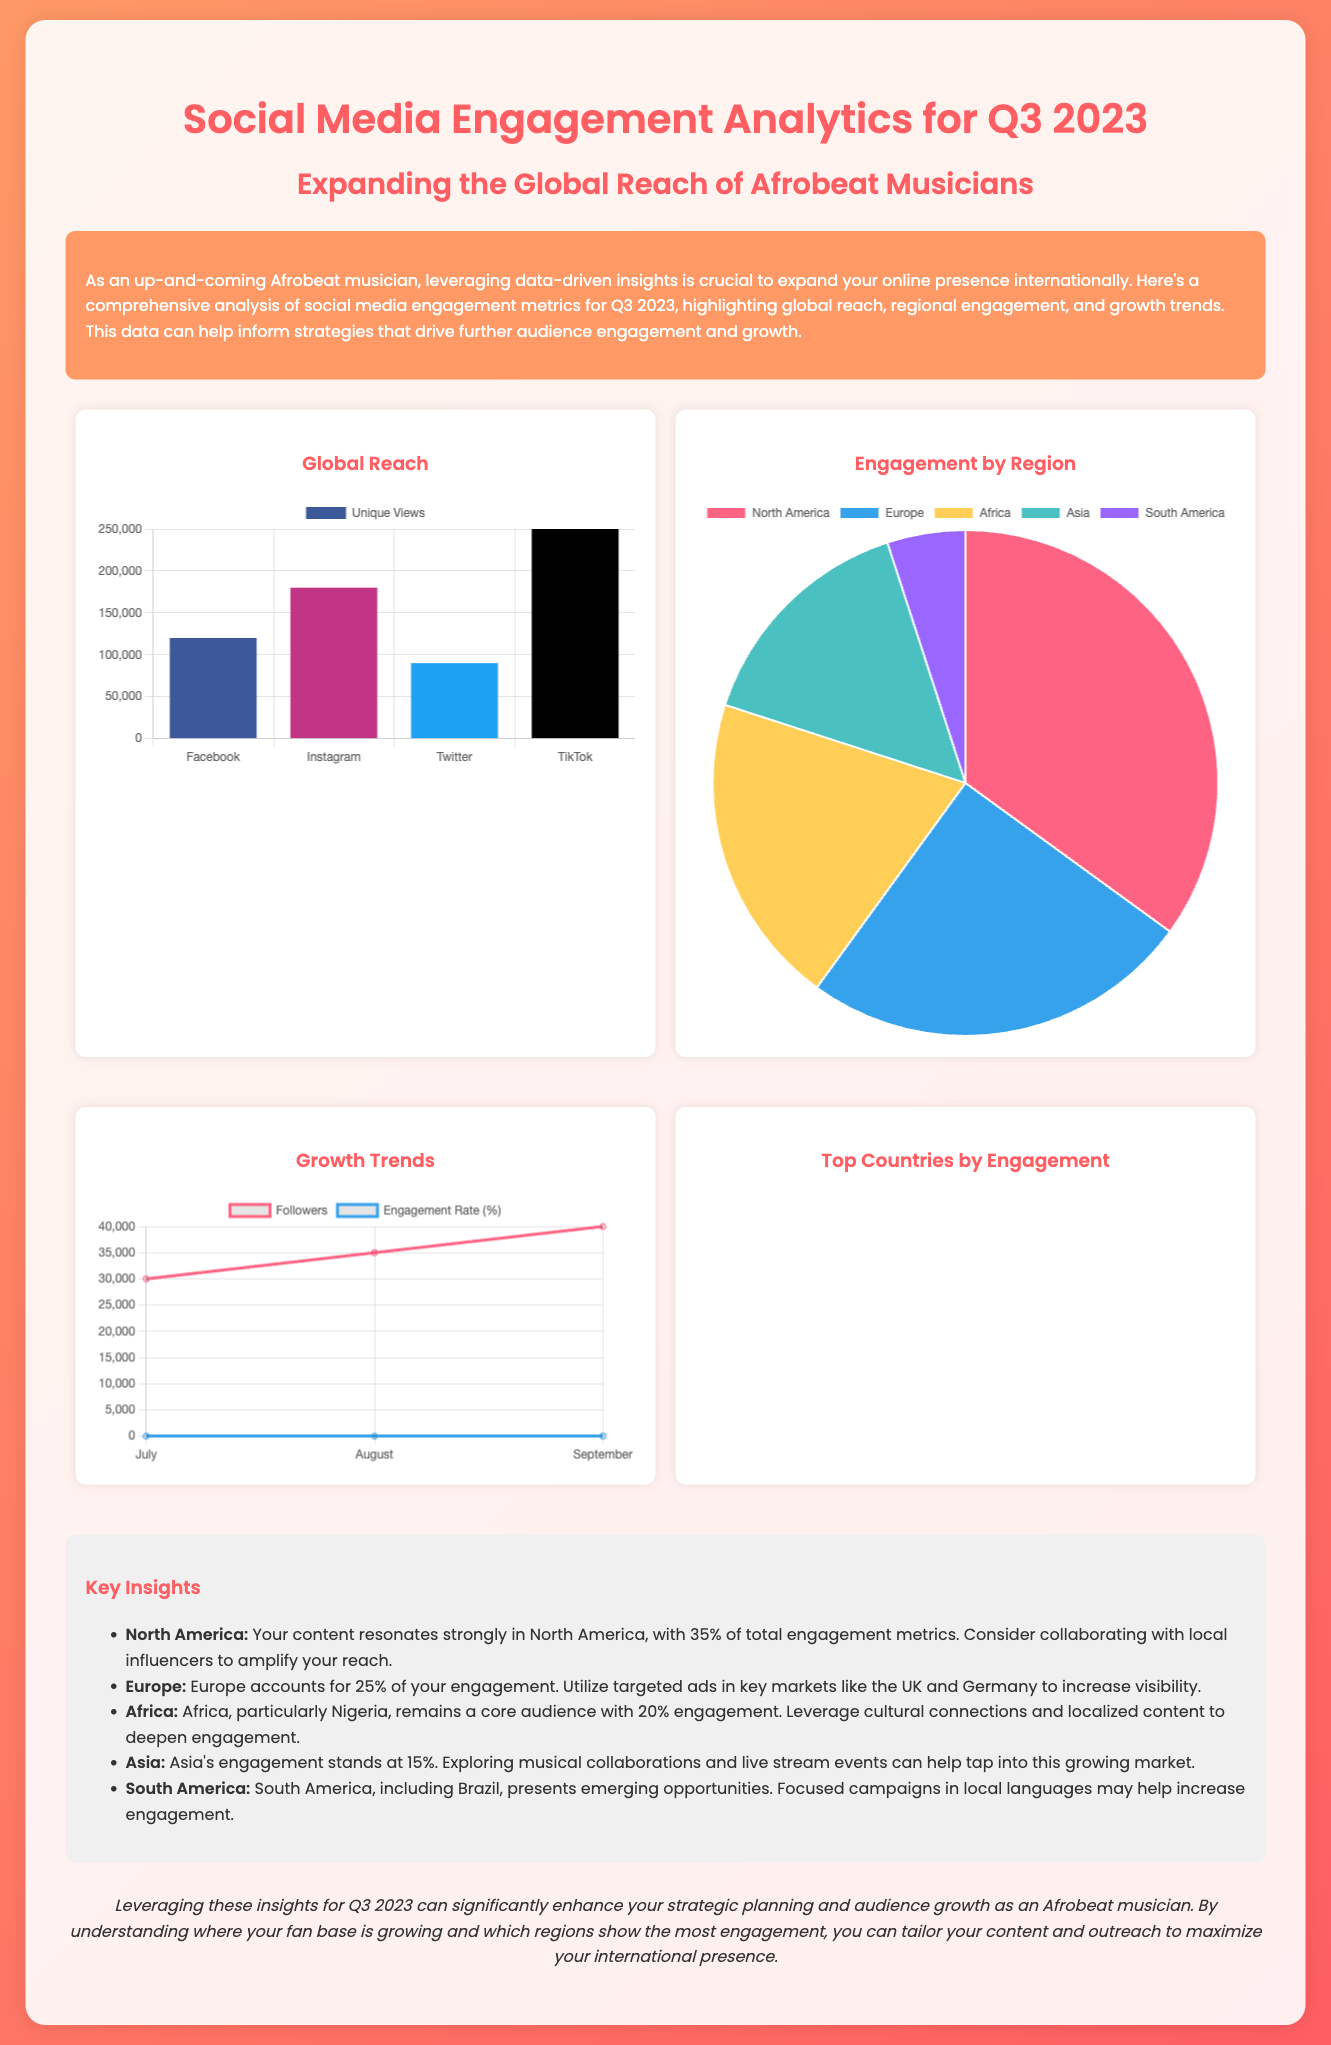What is the total engagement percentage from North America? The total engagement percentage from North America is explicitly stated in the insights section, which highlights that it is 35%.
Answer: 35% What region accounts for the largest portion of engagement? The insights reveal that North America accounts for the largest portion of engagement at 35%.
Answer: North America Which platform has the highest unique views? The global reach chart indicates that TikTok has the highest unique views, reported as 250,000.
Answer: TikTok What is the follower count in September? The growth trends chart specifies that the follower count in September is 40,000.
Answer: 40000 Which region has the lowest engagement? The engagement by region pie chart illustrates that South America has the lowest engagement at 5%.
Answer: South America What notable insights are there for Africa? The insights section indicates that Africa has a 20% engagement rate, specifically mentioning Nigeria as a core audience.
Answer: 20% What was the engagement rate in August? The growth trends data shows that the engagement rate in August was 3.0%.
Answer: 3.0% Which country has the highest engagement rate? The top countries chart reveals that the United States has the highest engagement rate at 40%.
Answer: United States 